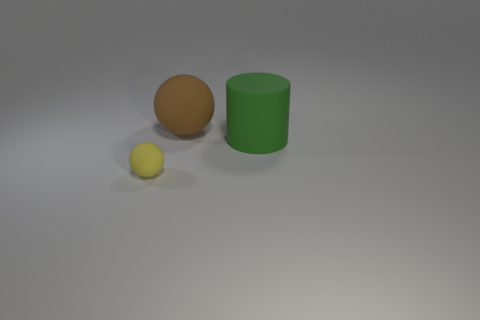Are there any other things that have the same size as the cylinder?
Give a very brief answer. Yes. What number of cylinders are the same size as the brown ball?
Provide a succinct answer. 1. Is the number of large brown balls that are in front of the green matte thing less than the number of cylinders to the right of the brown rubber ball?
Ensure brevity in your answer.  Yes. What number of metal objects are either big red cylinders or large cylinders?
Offer a terse response. 0. There is a big brown thing; what shape is it?
Your response must be concise. Sphere. There is a brown object that is the same size as the matte cylinder; what is it made of?
Your response must be concise. Rubber. What number of large objects are yellow objects or blue cylinders?
Offer a terse response. 0. Are there any green objects?
Make the answer very short. Yes. There is a yellow sphere that is made of the same material as the big green object; what size is it?
Your answer should be compact. Small. Are the green cylinder and the small object made of the same material?
Your answer should be compact. Yes. 